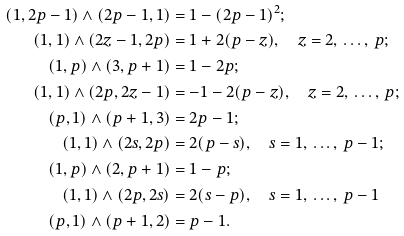<formula> <loc_0><loc_0><loc_500><loc_500>( 1 , 2 p - 1 ) \wedge ( 2 p - 1 , 1 ) & = 1 - ( 2 p - 1 ) ^ { 2 } ; \\ ( 1 , 1 ) \wedge ( 2 z - 1 , 2 p ) & = 1 + 2 ( p - z ) , \quad z = 2 , \, \dots , \, p ; \\ ( 1 , p ) \wedge ( 3 , p + 1 ) & = 1 - 2 p ; \\ ( 1 , 1 ) \wedge ( 2 p , 2 z - 1 ) & = - 1 - 2 ( p - z ) , \quad z = 2 , \, \dots , \, p ; \\ ( p , 1 ) \wedge ( p + 1 , 3 ) & = 2 p - 1 ; \\ ( 1 , 1 ) \wedge ( 2 s , 2 p ) & = 2 ( p - s ) , \quad s = 1 , \, \dots , \, p - 1 ; \\ ( 1 , p ) \wedge ( 2 , p + 1 ) & = 1 - p ; \\ ( 1 , 1 ) \wedge ( 2 p , 2 s ) & = 2 ( s - p ) , \quad s = 1 , \, \dots , \, p - 1 \\ ( p , 1 ) \wedge ( p + 1 , 2 ) & = p - 1 .</formula> 